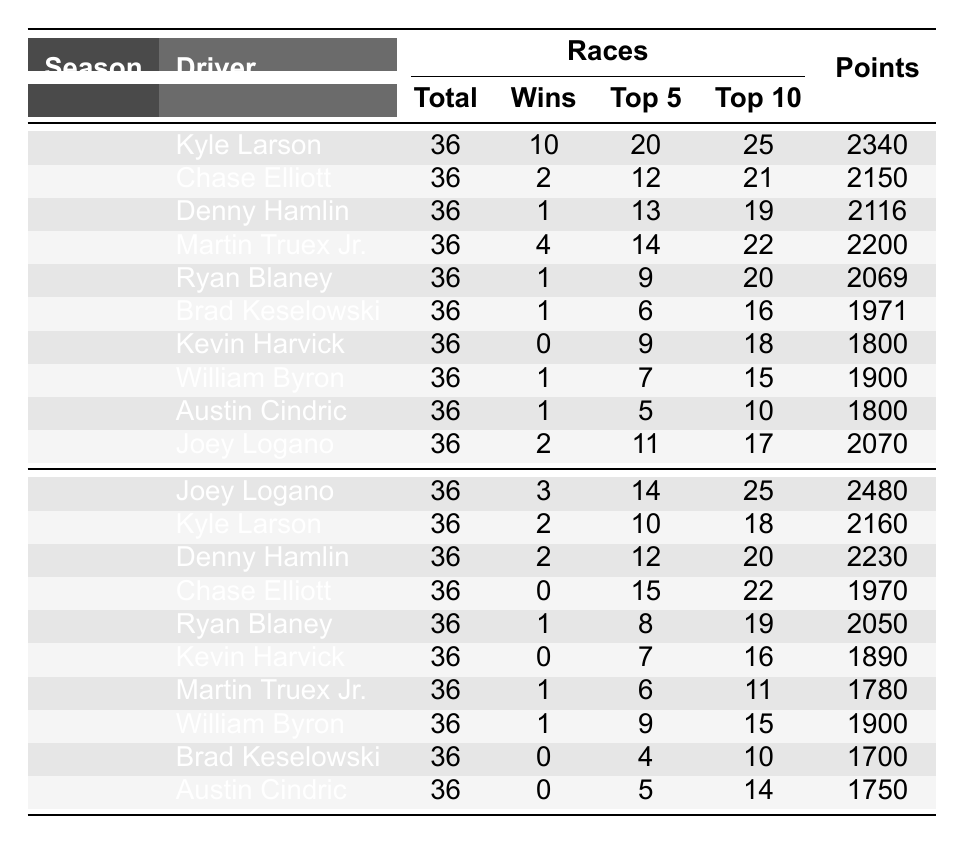What driver had the most wins in the 2021 season? Kyle Larson had 10 wins in the 2021 season as indicated in the "Wins" column for that season.
Answer: Kyle Larson Which season saw Joey Logano performing better in terms of total points? In the 2022 season, Joey Logano earned 2480 points, compared to 2070 points in the 2021 season, indicating he performed better in 2022.
Answer: 2022 How many total races did Denny Hamlin race across both seasons? Denny Hamlin participated in 36 races during each season, so total races = 36 (2021) + 36 (2022) = 72 races.
Answer: 72 Did Chase Elliott achieve any wins in the 2022 season? In the 2022 season, Chase Elliott had 0 wins as it is specified in the "Wins" column for that season.
Answer: No Who had the highest average finish in the 2021 season? Kyle Larson had the highest average finish of 9.4, which is referenced in the "AvgFinish" column for that season.
Answer: 9.4 In which season did Martin Truex Jr. have more top 10 finishes? Martin Truex Jr. had 22 top 10 finishes in 2021 and 11 in 2022, hence 2021 saw him with more.
Answer: 2021 Calculate the average points earned by Ryan Blaney across both seasons. Ryan Blaney scored 2069 points in 2021 and 2050 points in 2022, average = (2069 + 2050) / 2 = 2059.5 points.
Answer: 2059.5 How many drivers had 0 wins in the 2022 season? In the 2022 season, both Kevin Harvick and Austin Cindric had 0 wins, tallying up to 2 drivers without any wins.
Answer: 2 Is it true that Kevin Harvick had more top 10 finishes than Brad Keselowski in the 2021 season? Yes, Kevin Harvick had 18 top 10 finishes compared to Brad Keselowski's 16 in the 2021 season, confirming the statement.
Answer: Yes Which driver consistently finished with the lowest average finish across both seasons? Austin Cindric had the lowest average finish of 15.4 in 2021 and 14.4 in 2022, averaging 14.9 across both seasons.
Answer: Austin Cindric 